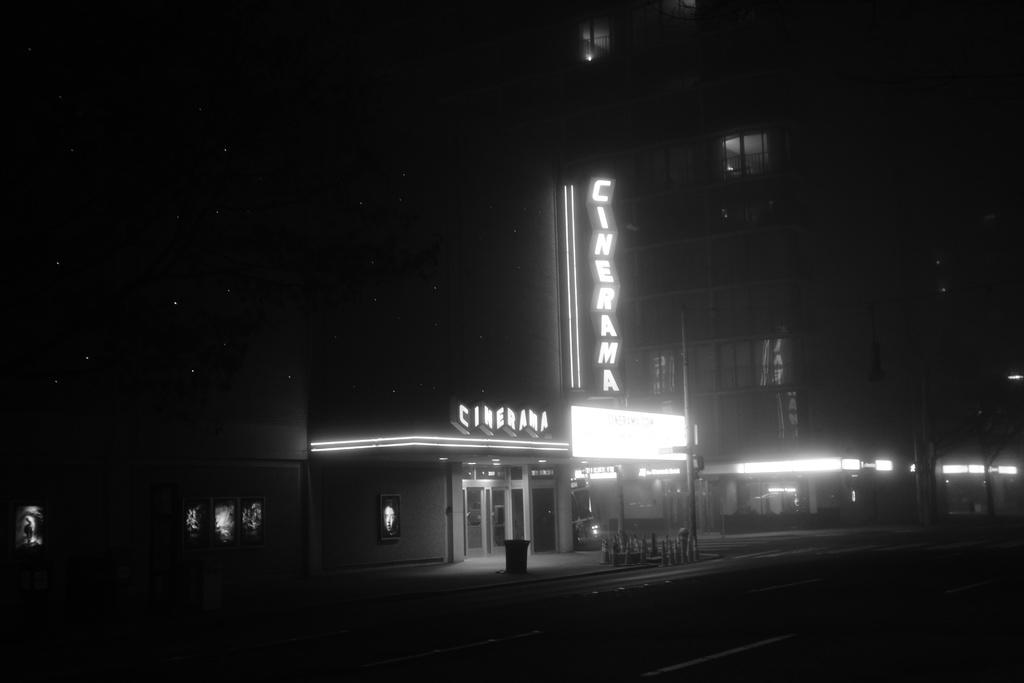What time of day was the picture taken? The picture was taken at night. What is the main subject in the center of the image? There is a hoarding in the center of the image. What other objects are in the center of the image? There are chairs and a dustbin in the center of the image. What can be seen in the background of the image? There are buildings and windows visible in the image. Can you see the mother holding the arm of a pig in the image? There is no mother or pig present in the image. 